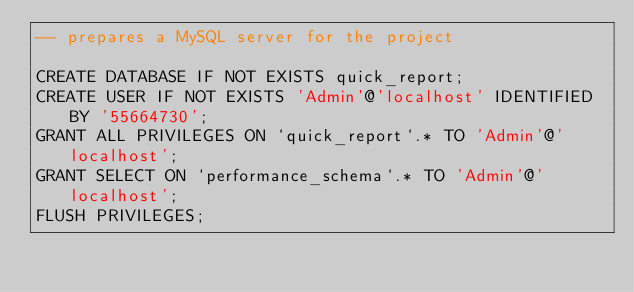Convert code to text. <code><loc_0><loc_0><loc_500><loc_500><_SQL_>-- prepares a MySQL server for the project

CREATE DATABASE IF NOT EXISTS quick_report;
CREATE USER IF NOT EXISTS 'Admin'@'localhost' IDENTIFIED BY '55664730';
GRANT ALL PRIVILEGES ON `quick_report`.* TO 'Admin'@'localhost';
GRANT SELECT ON `performance_schema`.* TO 'Admin'@'localhost';
FLUSH PRIVILEGES;

</code> 